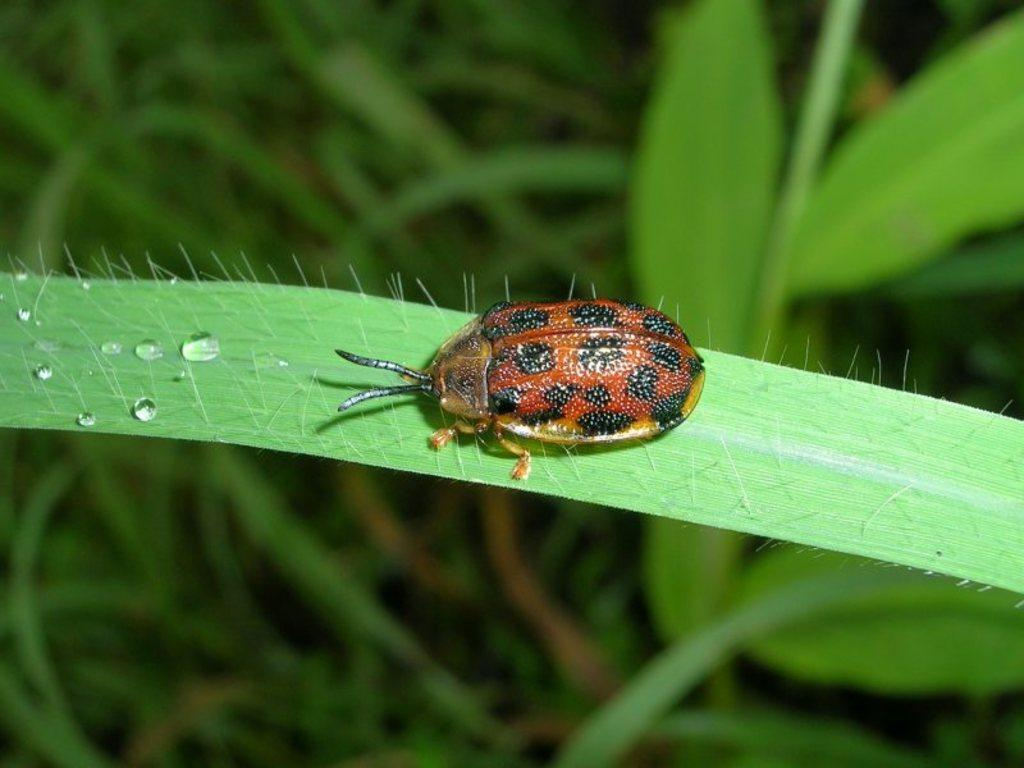What is on the leaf in the image? There is a bug on a leaf in the image. What else can be seen in the image besides the bug and leaf? There are plants visible in the image. Where is the bomb located in the image? There is no bomb present in the image. What type of hill can be seen in the background of the image? There is no hill visible in the image; it features a bug on a leaf and plants. 